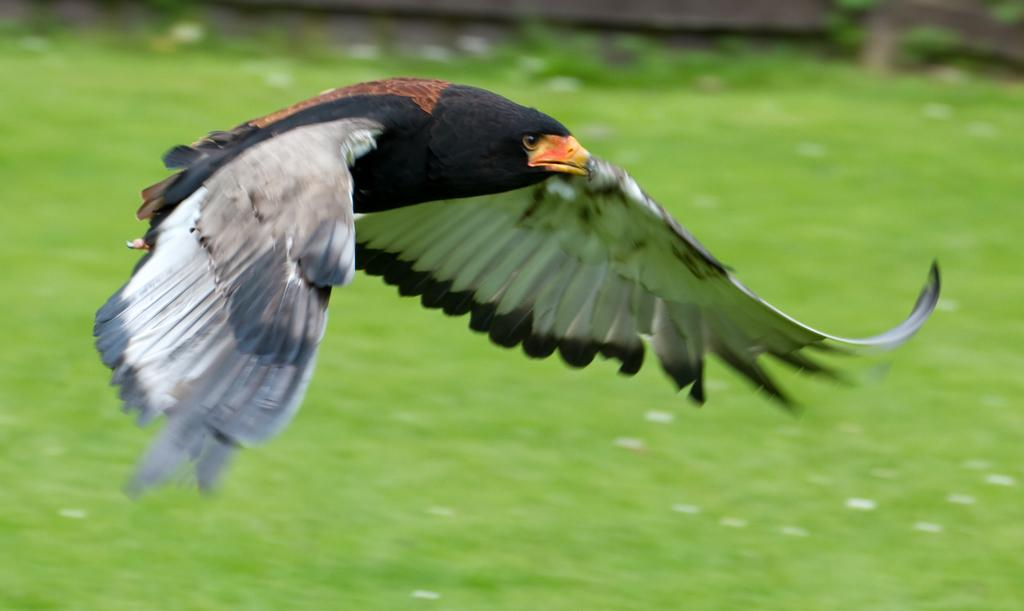What is the main subject of the image? There is a bird in the image. What is the bird doing in the image? The bird is flying. What type of surface is the bird flying over? The bird is flying over a grass surface. How is the background of the bird depicted in the image? The background of the bird is blurred. What type of juice can be seen in the image? There is no juice present in the image; it features a bird flying over a grass surface. Is the bird flying through a yard or a window in the image? The bird is flying over a grass surface, and there is no indication of a yard or window in the image. 